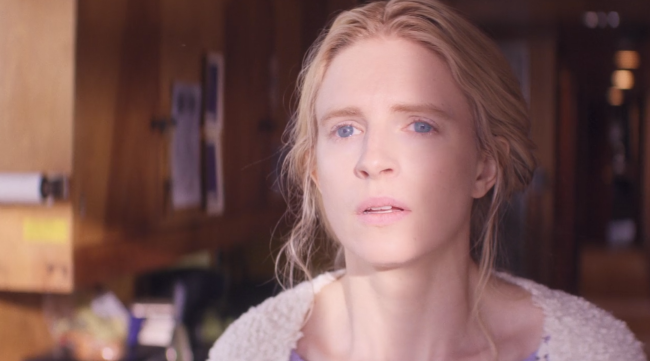Can you describe the setting in more detail? In the setting captured by the image, the woman stands out prominently with her light hair and white sweater, contrasting against the darker wooden walls of the room. The wood paneling gives the room a rustic and cozy feel. Low lighting enhances the warmth of the wooden tones, suggesting it might be early morning or late afternoon. Near the back, there is a desk with various items, possibly indicating the room serves a dual purpose as a living space and a work area. The window in the background allows soft, natural light to fill the space, creating a serene atmosphere. 